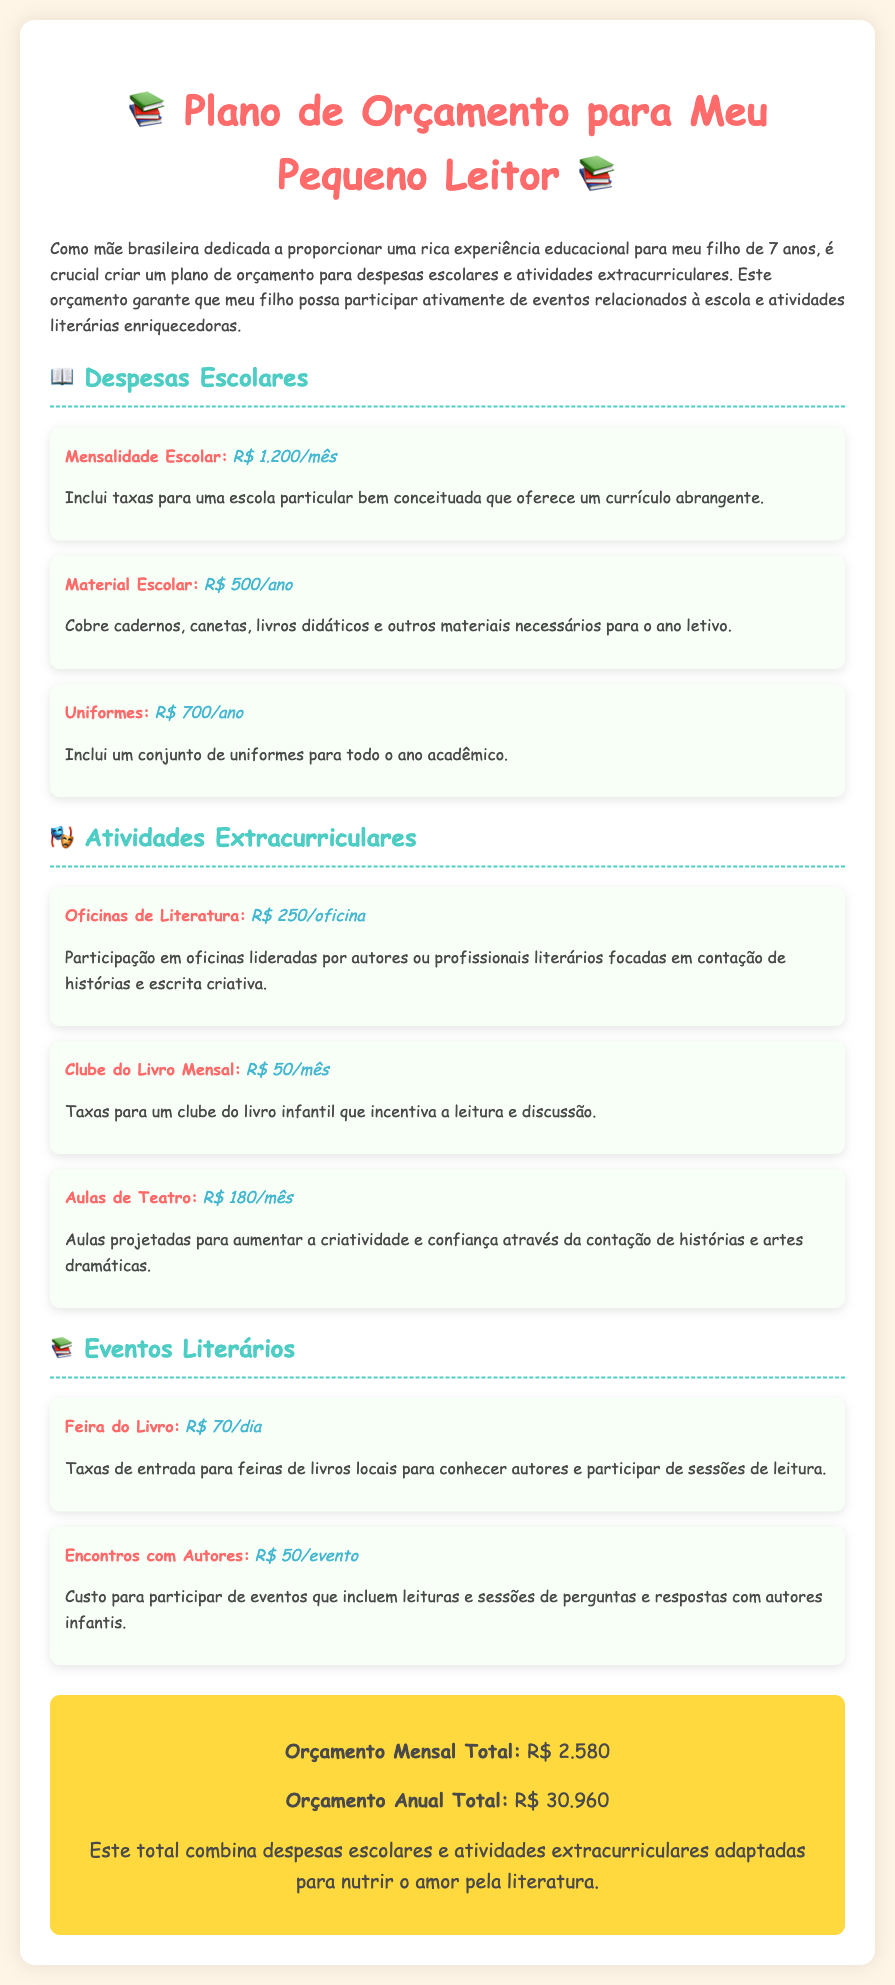Qual é o custo da mensalidade escolar? O custo da mensalidade escolar é destacado no segmento de despesas escolares.
Answer: R$ 1.200/mês Qual é o total do orçamento anual? O total do orçamento anual é a soma de todas as despesas escolares e atividades extracurriculares durante o ano.
Answer: R$ 30.960 Quanto custa participar de uma oficina de literatura? O custo para participação em oficinas de literatura é mencionado nas atividades extracurriculares.
Answer: R$ 250/oficina Qual é a taxa mensal do clube do livro? O valor da taxa mensal do clube do livro está indicado na seção de atividades extracurriculares.
Answer: R$ 50/mês Quantos reais eu precisaria gastar para levar meu filho à feira do livro durante um dia? A taxa de entrada para a feira do livro é listada como um custo por dia.
Answer: R$ 70/dia Qual é o custo total das aulas de teatro em um ano? Para calcular o custo total em um ano, multiplicamos o valor mensal pelas 12 meses do ano.
Answer: R$ 2.160 Qual é o valor cobrado para eventos com autores? O custo para participar de eventos com autores é especificado na seção de eventos literários.
Answer: R$ 50/evento Qual item tem o maior custo anual no orçamento? O item com o maior custo anual é destacado nas despesas escolares.
Answer: Mensalidade Escolar Quantas oficinas de literatura poderiam ser pagas com o orçamento anual total? Para calcular isso, dividimos o orçamento anual total pelo custo de uma oficina de literatura.
Answer: 123 oficinas 